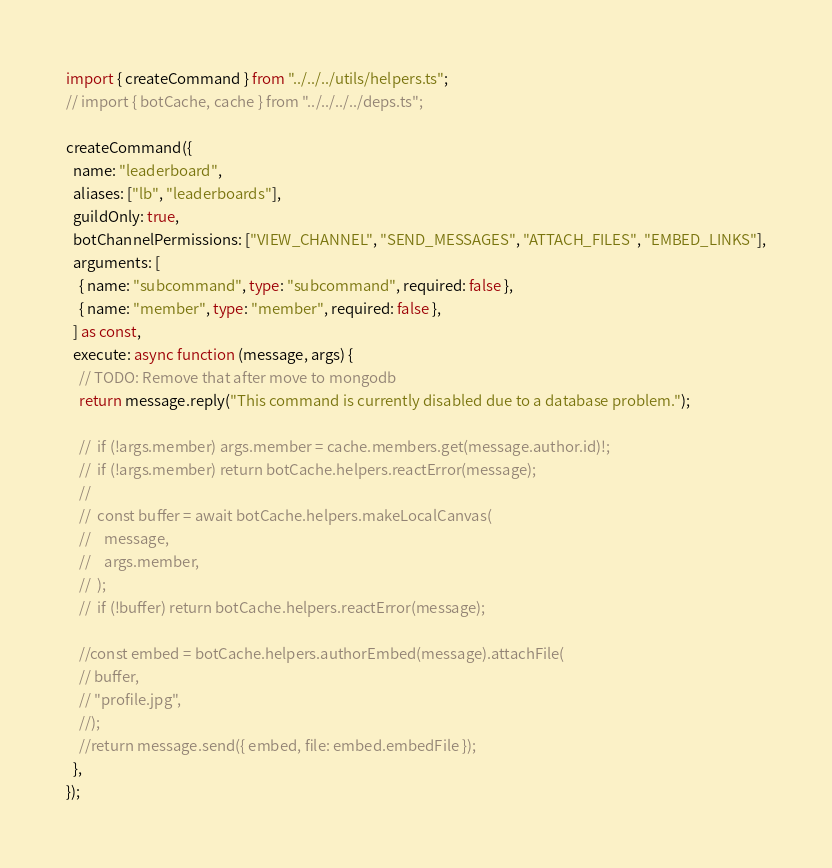<code> <loc_0><loc_0><loc_500><loc_500><_TypeScript_>import { createCommand } from "../../../utils/helpers.ts";
// import { botCache, cache } from "../../../../deps.ts";

createCommand({
  name: "leaderboard",
  aliases: ["lb", "leaderboards"],
  guildOnly: true,
  botChannelPermissions: ["VIEW_CHANNEL", "SEND_MESSAGES", "ATTACH_FILES", "EMBED_LINKS"],
  arguments: [
    { name: "subcommand", type: "subcommand", required: false },
    { name: "member", type: "member", required: false },
  ] as const,
  execute: async function (message, args) {
    // TODO: Remove that after move to mongodb
    return message.reply("This command is currently disabled due to a database problem.");

    //  if (!args.member) args.member = cache.members.get(message.author.id)!;
    //  if (!args.member) return botCache.helpers.reactError(message);
    //
    //  const buffer = await botCache.helpers.makeLocalCanvas(
    //    message,
    //    args.member,
    //  );
    //  if (!buffer) return botCache.helpers.reactError(message);

    //const embed = botCache.helpers.authorEmbed(message).attachFile(
    // buffer,
    // "profile.jpg",
    //);
    //return message.send({ embed, file: embed.embedFile });
  },
});
</code> 